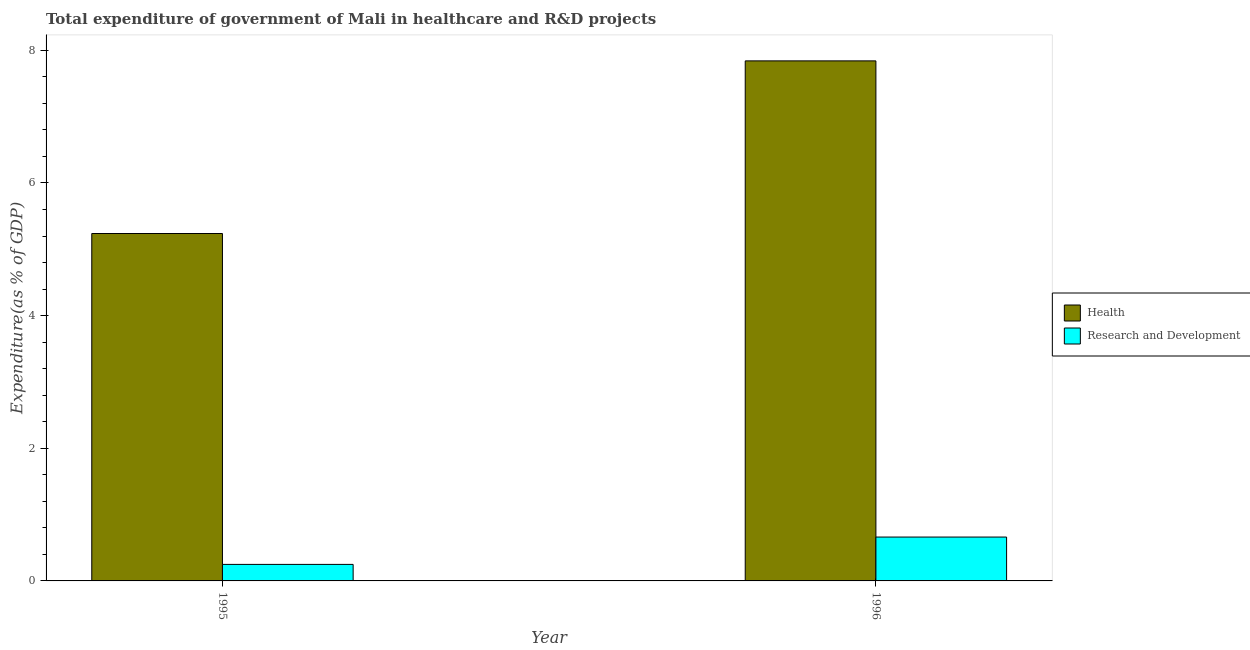How many different coloured bars are there?
Your response must be concise. 2. Are the number of bars per tick equal to the number of legend labels?
Provide a succinct answer. Yes. How many bars are there on the 1st tick from the left?
Keep it short and to the point. 2. What is the expenditure in r&d in 1996?
Your response must be concise. 0.66. Across all years, what is the maximum expenditure in r&d?
Offer a very short reply. 0.66. Across all years, what is the minimum expenditure in r&d?
Keep it short and to the point. 0.25. In which year was the expenditure in r&d maximum?
Your answer should be very brief. 1996. In which year was the expenditure in r&d minimum?
Provide a short and direct response. 1995. What is the total expenditure in healthcare in the graph?
Your answer should be compact. 13.08. What is the difference between the expenditure in r&d in 1995 and that in 1996?
Provide a succinct answer. -0.41. What is the difference between the expenditure in healthcare in 1995 and the expenditure in r&d in 1996?
Provide a short and direct response. -2.6. What is the average expenditure in r&d per year?
Offer a terse response. 0.46. In the year 1995, what is the difference between the expenditure in r&d and expenditure in healthcare?
Ensure brevity in your answer.  0. In how many years, is the expenditure in healthcare greater than 1.6 %?
Ensure brevity in your answer.  2. What is the ratio of the expenditure in healthcare in 1995 to that in 1996?
Your answer should be compact. 0.67. What does the 1st bar from the left in 1996 represents?
Ensure brevity in your answer.  Health. What does the 1st bar from the right in 1995 represents?
Ensure brevity in your answer.  Research and Development. How many bars are there?
Give a very brief answer. 4. What is the difference between two consecutive major ticks on the Y-axis?
Ensure brevity in your answer.  2. Are the values on the major ticks of Y-axis written in scientific E-notation?
Offer a very short reply. No. Where does the legend appear in the graph?
Provide a short and direct response. Center right. How many legend labels are there?
Offer a very short reply. 2. What is the title of the graph?
Your answer should be compact. Total expenditure of government of Mali in healthcare and R&D projects. Does "By country of asylum" appear as one of the legend labels in the graph?
Offer a very short reply. No. What is the label or title of the X-axis?
Provide a succinct answer. Year. What is the label or title of the Y-axis?
Ensure brevity in your answer.  Expenditure(as % of GDP). What is the Expenditure(as % of GDP) of Health in 1995?
Offer a very short reply. 5.24. What is the Expenditure(as % of GDP) in Research and Development in 1995?
Your answer should be very brief. 0.25. What is the Expenditure(as % of GDP) of Health in 1996?
Offer a very short reply. 7.84. What is the Expenditure(as % of GDP) of Research and Development in 1996?
Ensure brevity in your answer.  0.66. Across all years, what is the maximum Expenditure(as % of GDP) in Health?
Make the answer very short. 7.84. Across all years, what is the maximum Expenditure(as % of GDP) of Research and Development?
Keep it short and to the point. 0.66. Across all years, what is the minimum Expenditure(as % of GDP) of Health?
Offer a terse response. 5.24. Across all years, what is the minimum Expenditure(as % of GDP) of Research and Development?
Give a very brief answer. 0.25. What is the total Expenditure(as % of GDP) of Health in the graph?
Your answer should be very brief. 13.08. What is the total Expenditure(as % of GDP) in Research and Development in the graph?
Your answer should be compact. 0.91. What is the difference between the Expenditure(as % of GDP) of Health in 1995 and that in 1996?
Keep it short and to the point. -2.6. What is the difference between the Expenditure(as % of GDP) in Research and Development in 1995 and that in 1996?
Keep it short and to the point. -0.41. What is the difference between the Expenditure(as % of GDP) of Health in 1995 and the Expenditure(as % of GDP) of Research and Development in 1996?
Your answer should be compact. 4.58. What is the average Expenditure(as % of GDP) of Health per year?
Make the answer very short. 6.54. What is the average Expenditure(as % of GDP) of Research and Development per year?
Offer a very short reply. 0.46. In the year 1995, what is the difference between the Expenditure(as % of GDP) of Health and Expenditure(as % of GDP) of Research and Development?
Keep it short and to the point. 4.99. In the year 1996, what is the difference between the Expenditure(as % of GDP) of Health and Expenditure(as % of GDP) of Research and Development?
Your answer should be compact. 7.18. What is the ratio of the Expenditure(as % of GDP) of Health in 1995 to that in 1996?
Your answer should be compact. 0.67. What is the ratio of the Expenditure(as % of GDP) of Research and Development in 1995 to that in 1996?
Make the answer very short. 0.38. What is the difference between the highest and the second highest Expenditure(as % of GDP) of Health?
Provide a short and direct response. 2.6. What is the difference between the highest and the second highest Expenditure(as % of GDP) of Research and Development?
Offer a terse response. 0.41. What is the difference between the highest and the lowest Expenditure(as % of GDP) in Health?
Keep it short and to the point. 2.6. What is the difference between the highest and the lowest Expenditure(as % of GDP) of Research and Development?
Offer a very short reply. 0.41. 